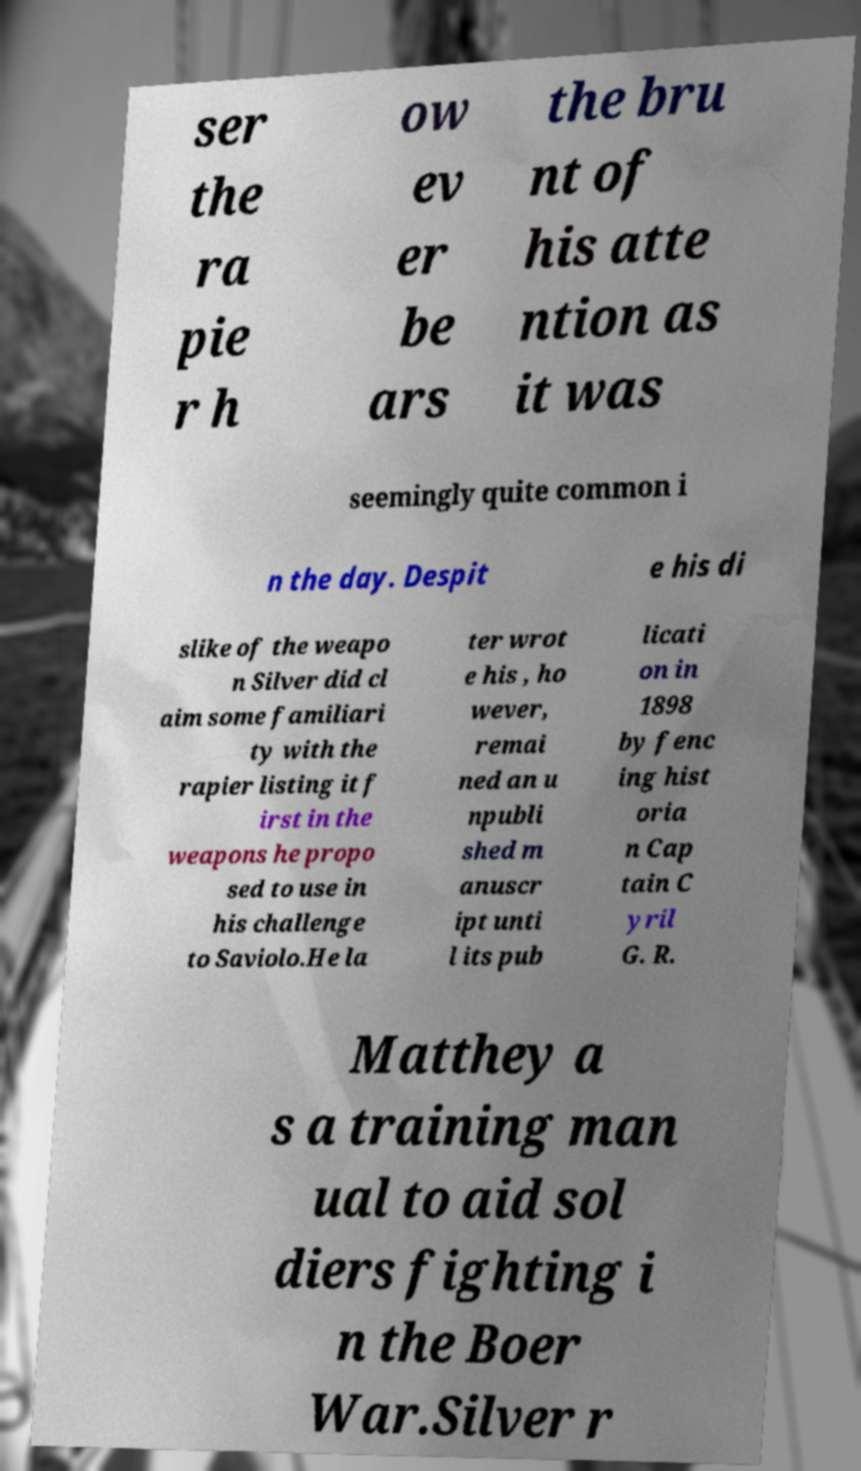There's text embedded in this image that I need extracted. Can you transcribe it verbatim? ser the ra pie r h ow ev er be ars the bru nt of his atte ntion as it was seemingly quite common i n the day. Despit e his di slike of the weapo n Silver did cl aim some familiari ty with the rapier listing it f irst in the weapons he propo sed to use in his challenge to Saviolo.He la ter wrot e his , ho wever, remai ned an u npubli shed m anuscr ipt unti l its pub licati on in 1898 by fenc ing hist oria n Cap tain C yril G. R. Matthey a s a training man ual to aid sol diers fighting i n the Boer War.Silver r 